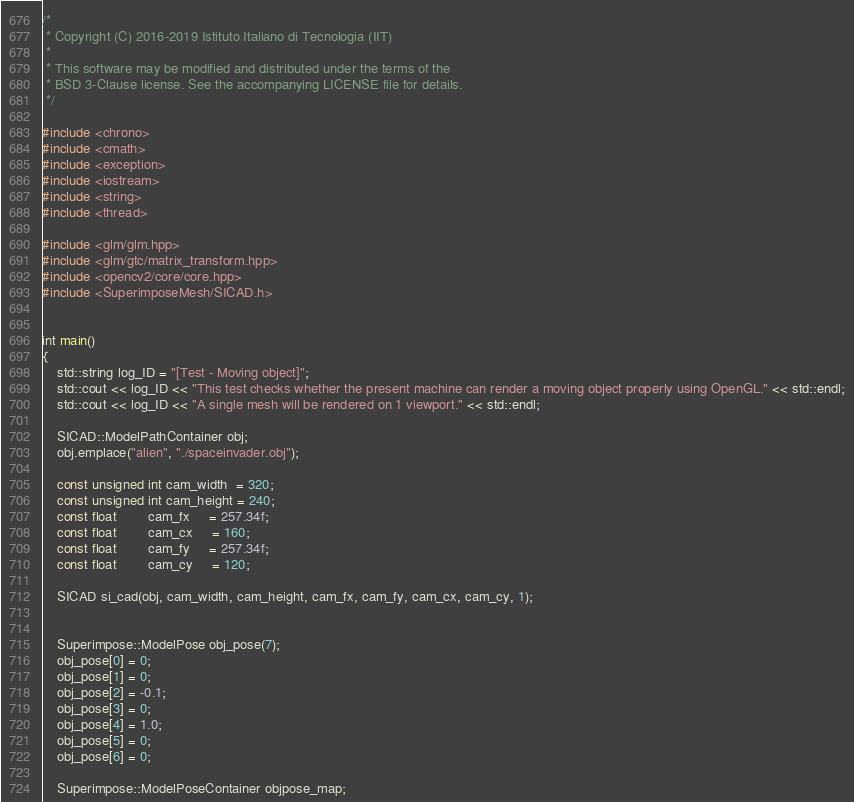<code> <loc_0><loc_0><loc_500><loc_500><_C++_>/*
 * Copyright (C) 2016-2019 Istituto Italiano di Tecnologia (IIT)
 *
 * This software may be modified and distributed under the terms of the
 * BSD 3-Clause license. See the accompanying LICENSE file for details.
 */

#include <chrono>
#include <cmath>
#include <exception>
#include <iostream>
#include <string>
#include <thread>

#include <glm/glm.hpp>
#include <glm/gtc/matrix_transform.hpp>
#include <opencv2/core/core.hpp>
#include <SuperimposeMesh/SICAD.h>


int main()
{
    std::string log_ID = "[Test - Moving object]";
    std::cout << log_ID << "This test checks whether the present machine can render a moving object properly using OpenGL." << std::endl;
    std::cout << log_ID << "A single mesh will be rendered on 1 viewport." << std::endl;

    SICAD::ModelPathContainer obj;
    obj.emplace("alien", "./spaceinvader.obj");

    const unsigned int cam_width  = 320;
    const unsigned int cam_height = 240;
    const float        cam_fx     = 257.34f;
    const float        cam_cx     = 160;
    const float        cam_fy     = 257.34f;
    const float        cam_cy     = 120;

    SICAD si_cad(obj, cam_width, cam_height, cam_fx, cam_fy, cam_cx, cam_cy, 1);

    
    Superimpose::ModelPose obj_pose(7);
    obj_pose[0] = 0;
    obj_pose[1] = 0;
    obj_pose[2] = -0.1;
    obj_pose[3] = 0;
    obj_pose[4] = 1.0;
    obj_pose[5] = 0;
    obj_pose[6] = 0;

    Superimpose::ModelPoseContainer objpose_map;</code> 